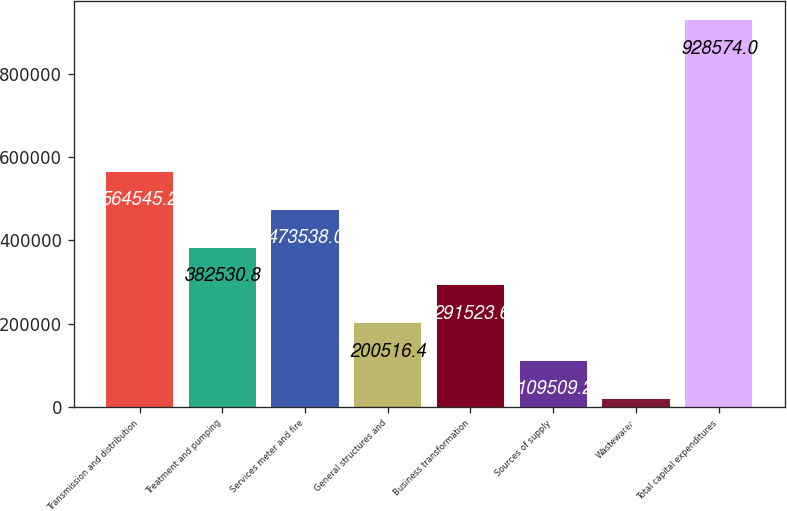<chart> <loc_0><loc_0><loc_500><loc_500><bar_chart><fcel>Transmission and distribution<fcel>Treatment and pumping<fcel>Services meter and fire<fcel>General structures and<fcel>Business transformation<fcel>Sources of supply<fcel>Wastewater<fcel>Total capital expenditures<nl><fcel>564545<fcel>382531<fcel>473538<fcel>200516<fcel>291524<fcel>109509<fcel>18502<fcel>928574<nl></chart> 